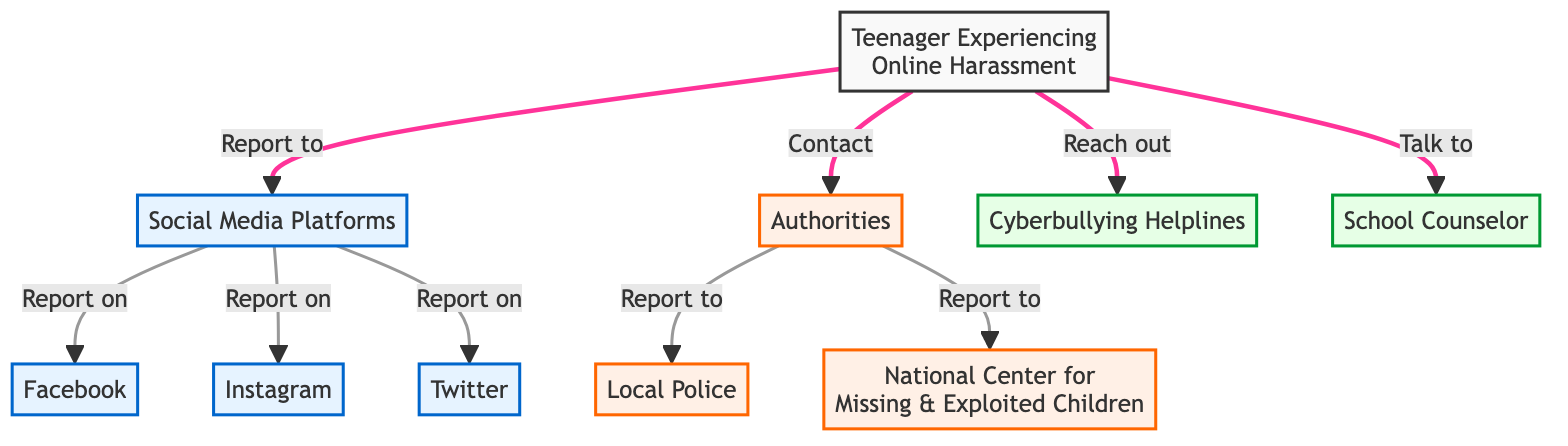What is the starting node in the diagram? The starting node is labeled "Teenager Experiencing Online Harassment," which indicates who is initiating the reporting process. This node serves as the origin point for all connections in the diagram.
Answer: Teenager Experiencing Online Harassment How many social media platforms are listed in the diagram? The diagram lists three social media platforms: Facebook, Instagram, and Twitter. These are the platforms where the teenager can report online harassment.
Answer: 3 Which authorities can the teenager contact regarding harassment? The authorities listed that the teenager can contact include Local Police and National Center for Missing & Exploited Children. These nodes directly connect to the "Authorities" node in the diagram.
Answer: Local Police and National Center for Missing & Exploited Children What type of action is shown from the "Teenager Experiencing Online Harassment" to "Social Media Platforms"? The action shown is "Report to," indicating the teenager's intention to report their experience on those platforms. This is a direct connection illustrating the teenager's course of action.
Answer: Report to What can the teenager do to seek support outside of social media? The teenager can "Reach out" to Cyberbullying Helplines or "Talk to" a School Counselor, which are support options clearly indicated in the diagram branching from the teenager's initial node.
Answer: Reach out or Talk to What direct reporting method is indicated between "Authorities" and "Local Police"? The method indicated is "Report to," suggesting a direct line of action the teenager has to inform the local police about their harassment experiences. This relationship emphasizes the authority’s role in the support process.
Answer: Report to Describe the connections between "Social Media Platforms" and the specific platforms listed. The connection is demonstrated by the edge labeled "Report on," indicating that the teenager can report harassment experiences specifically on the platforms of Facebook, Instagram, and Twitter that are grouped under "Social Media Platforms."
Answer: Report on What is the common action for the teenager towards authorities? The common action is to "Contact," which indicates the teenager can initiate communication with various authorities to report harassment cases. This underscores the proactive step the teenager can take.
Answer: Contact 